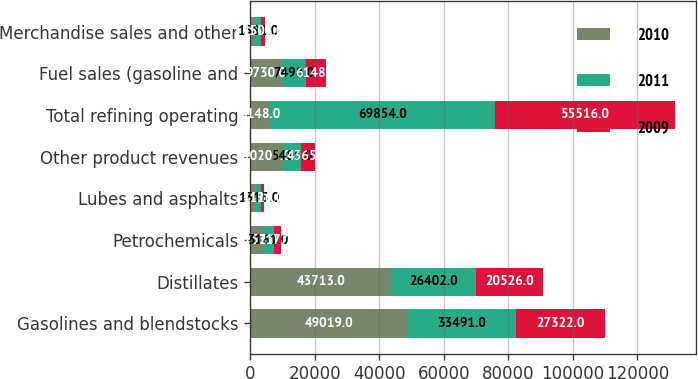Convert chart to OTSL. <chart><loc_0><loc_0><loc_500><loc_500><stacked_bar_chart><ecel><fcel>Gasolines and blendstocks<fcel>Distillates<fcel>Petrochemicals<fcel>Lubes and asphalts<fcel>Other product revenues<fcel>Total refining operating<fcel>Fuel sales (gasoline and<fcel>Merchandise sales and other<nl><fcel>2010<fcel>49019<fcel>43713<fcel>4253<fcel>1948<fcel>10205<fcel>6148<fcel>9730<fcel>1635<nl><fcel>2011<fcel>33491<fcel>26402<fcel>3161<fcel>1315<fcel>5485<fcel>69854<fcel>7498<fcel>1581<nl><fcel>2009<fcel>27322<fcel>20526<fcel>2177<fcel>1126<fcel>4365<fcel>55516<fcel>6148<fcel>1505<nl></chart> 